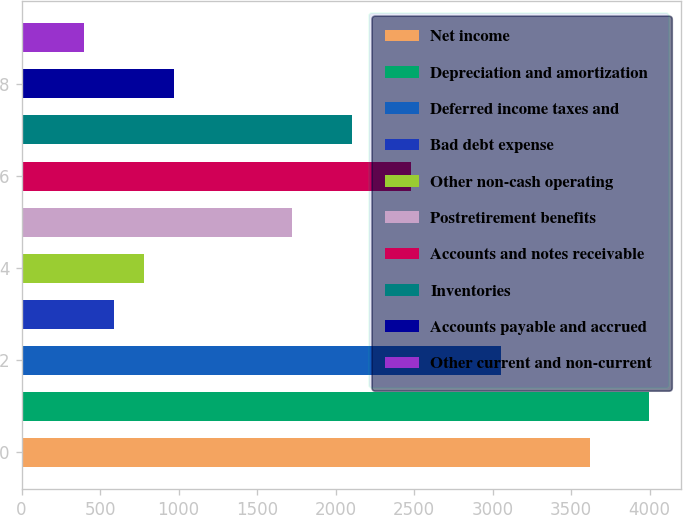Convert chart. <chart><loc_0><loc_0><loc_500><loc_500><bar_chart><fcel>Net income<fcel>Depreciation and amortization<fcel>Deferred income taxes and<fcel>Bad debt expense<fcel>Other non-cash operating<fcel>Postretirement benefits<fcel>Accounts and notes receivable<fcel>Inventories<fcel>Accounts payable and accrued<fcel>Other current and non-current<nl><fcel>3618.7<fcel>3997.3<fcel>3050.8<fcel>589.9<fcel>779.2<fcel>1725.7<fcel>2482.9<fcel>2104.3<fcel>968.5<fcel>400.6<nl></chart> 